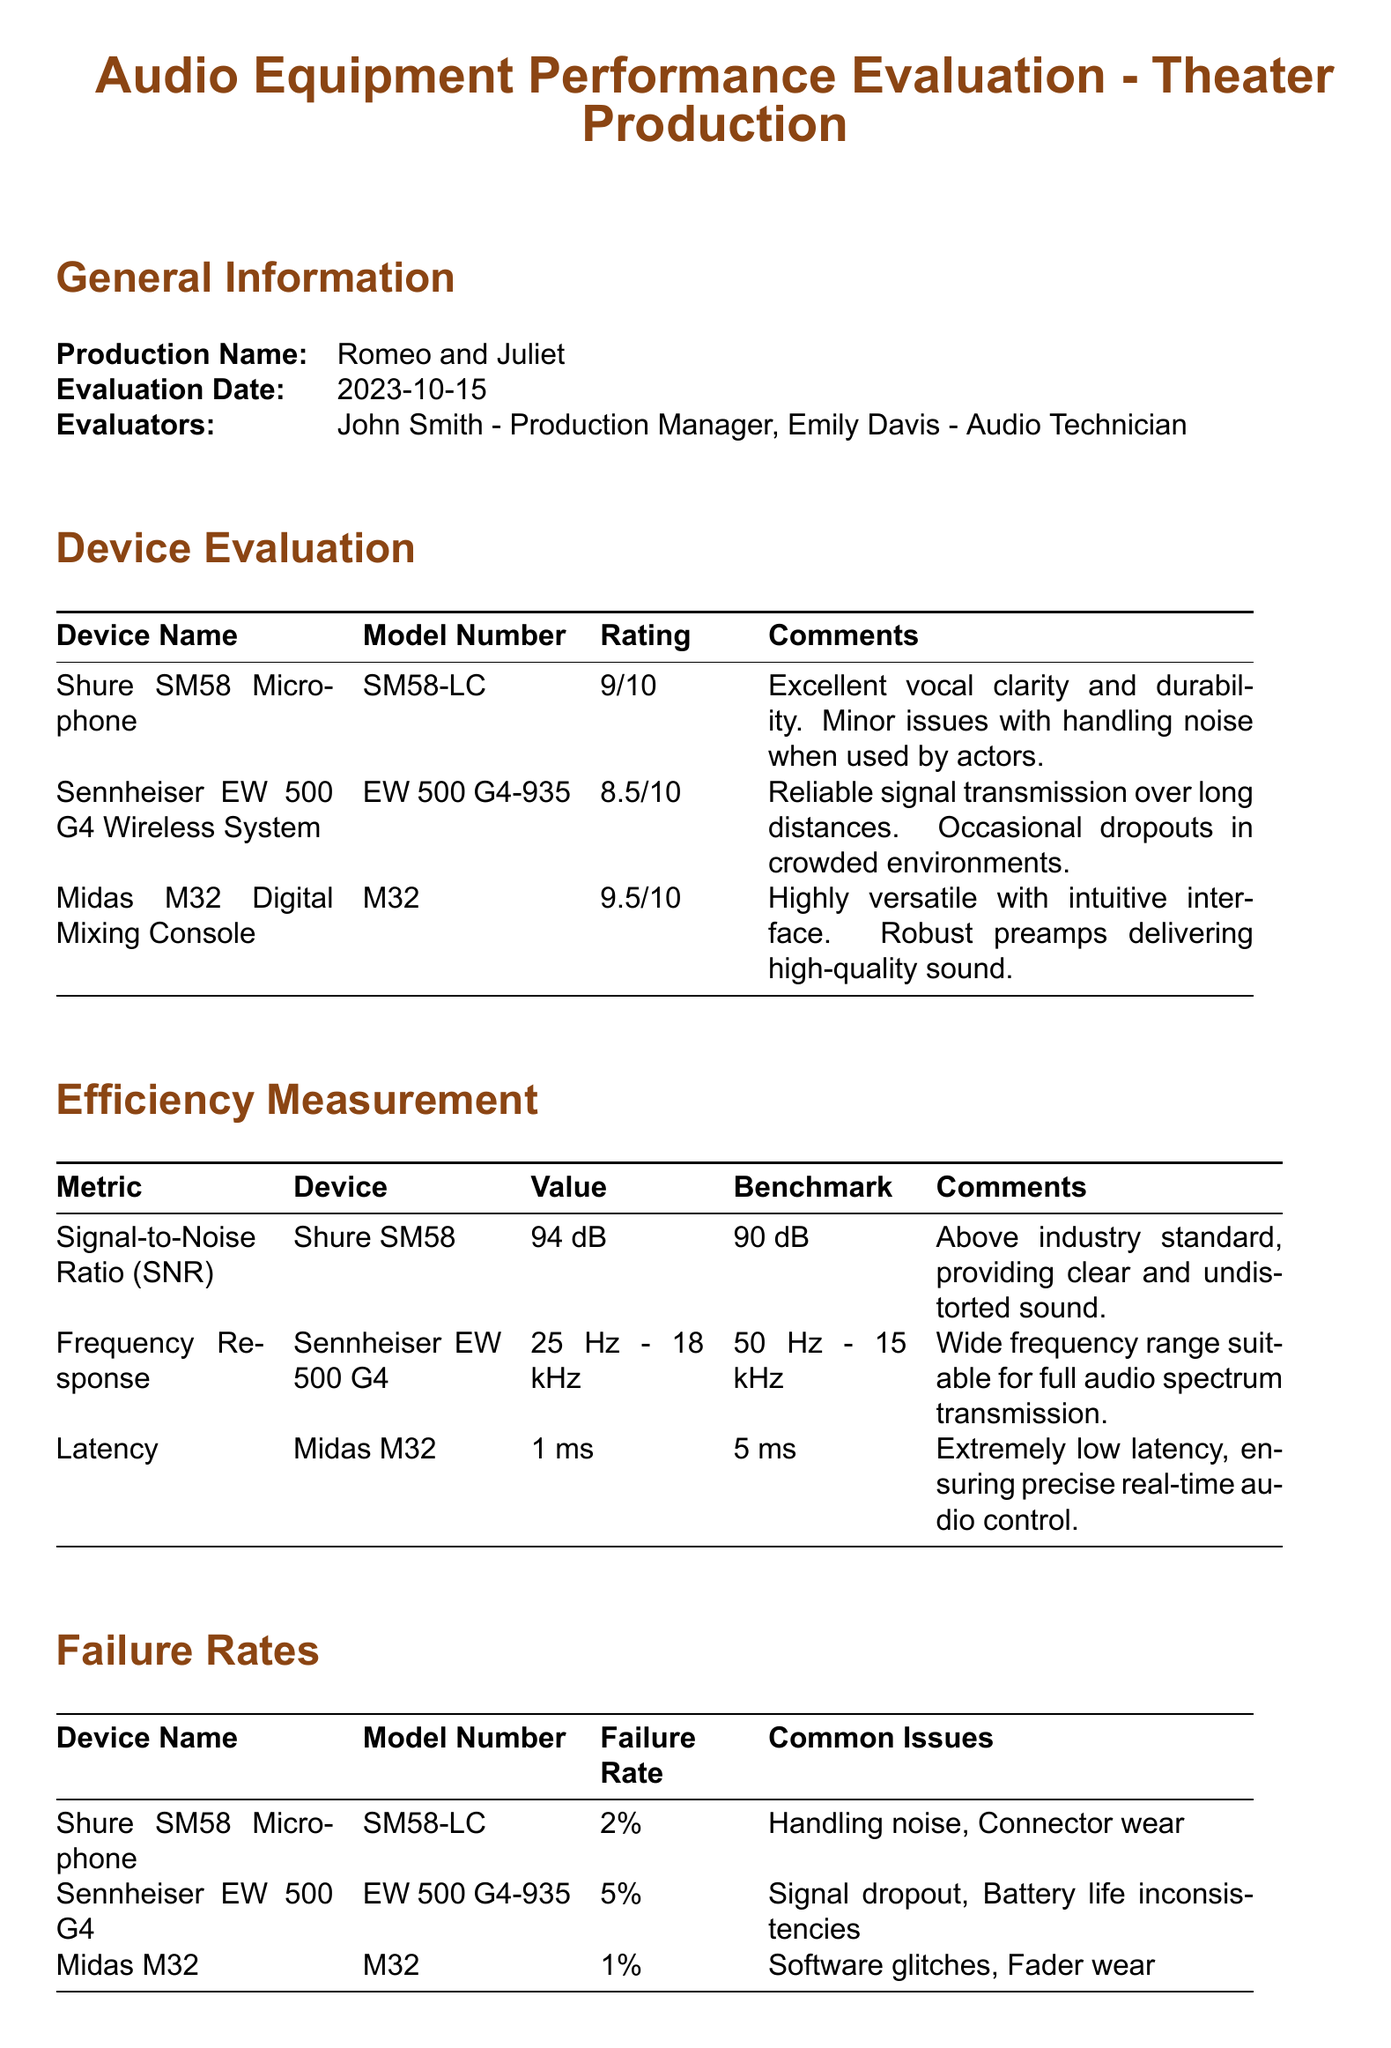What is the production name? The production name is provided in the general information section of the document.
Answer: Romeo and Juliet Who are the evaluators? The evaluators' names are listed under the general information section.
Answer: John Smith, Emily Davis What is the rating of the Midas M32 Digital Mixing Console? The rating is included in the device evaluation table for the Midas M32.
Answer: 9.5/10 What is the failure rate of the Sennheiser EW 500 G4 Wireless System? The failure rate is mentioned in the failure rates table for the Sennheiser EW 500 G4.
Answer: 5% What does the frequency response of the Sennheiser EW 500 G4 range from? The frequency response values are listed in the efficiency measurement section for the Sennheiser EW 500 G4.
Answer: 25 Hz - 18 kHz Which device has the lowest failure rate? The failure rates for each device are detailed in the failure rates table, allowing for a comparison to find the lowest.
Answer: Midas M32 What is one common issue for the Shure SM58 Microphone? Common issues for the Shure SM58 are noted in the failure rates table.
Answer: Handling noise What recommendation is made for the Midas M32? The recommendations are detailed in the summary and recommendations section.
Answer: Regular software updates and maintenance What is the signal-to-noise ratio for the Shure SM58? The signal-to-noise ratio is specified in the efficiency measurement section for the Shure SM58.
Answer: 94 dB 